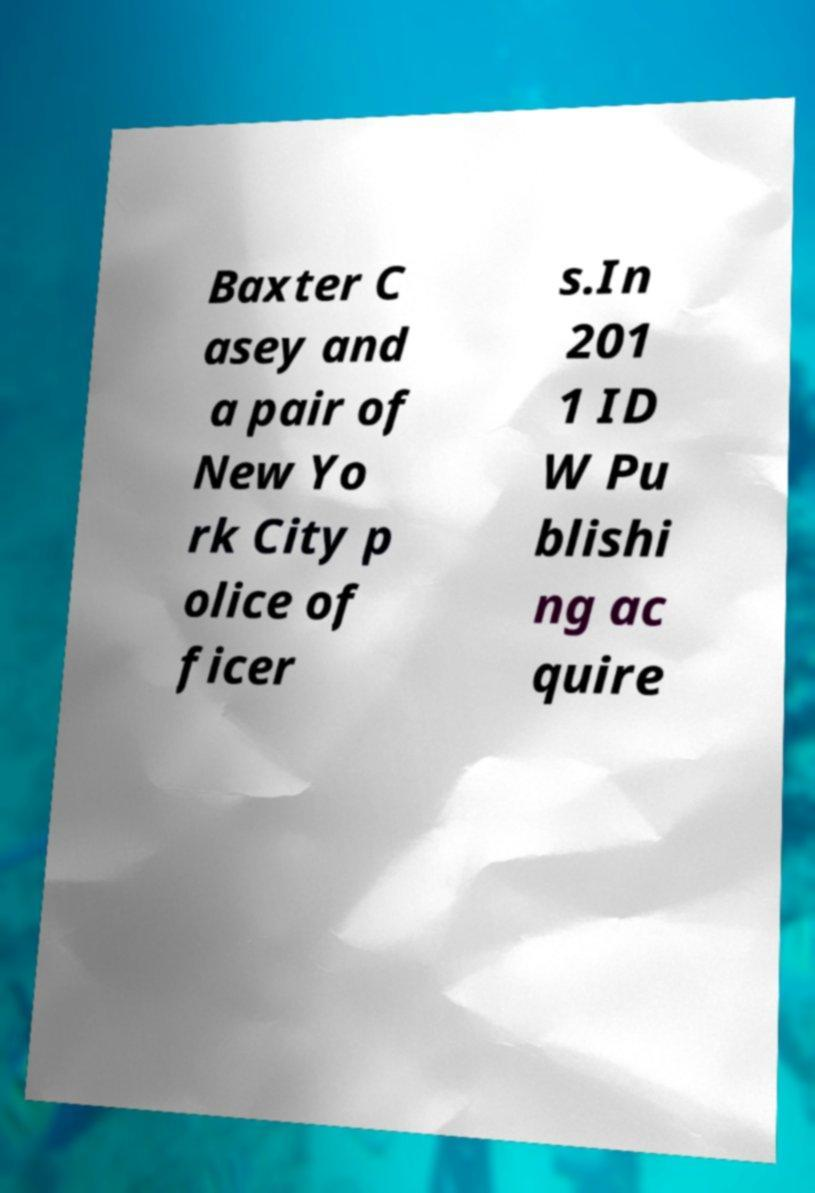Could you assist in decoding the text presented in this image and type it out clearly? Baxter C asey and a pair of New Yo rk City p olice of ficer s.In 201 1 ID W Pu blishi ng ac quire 